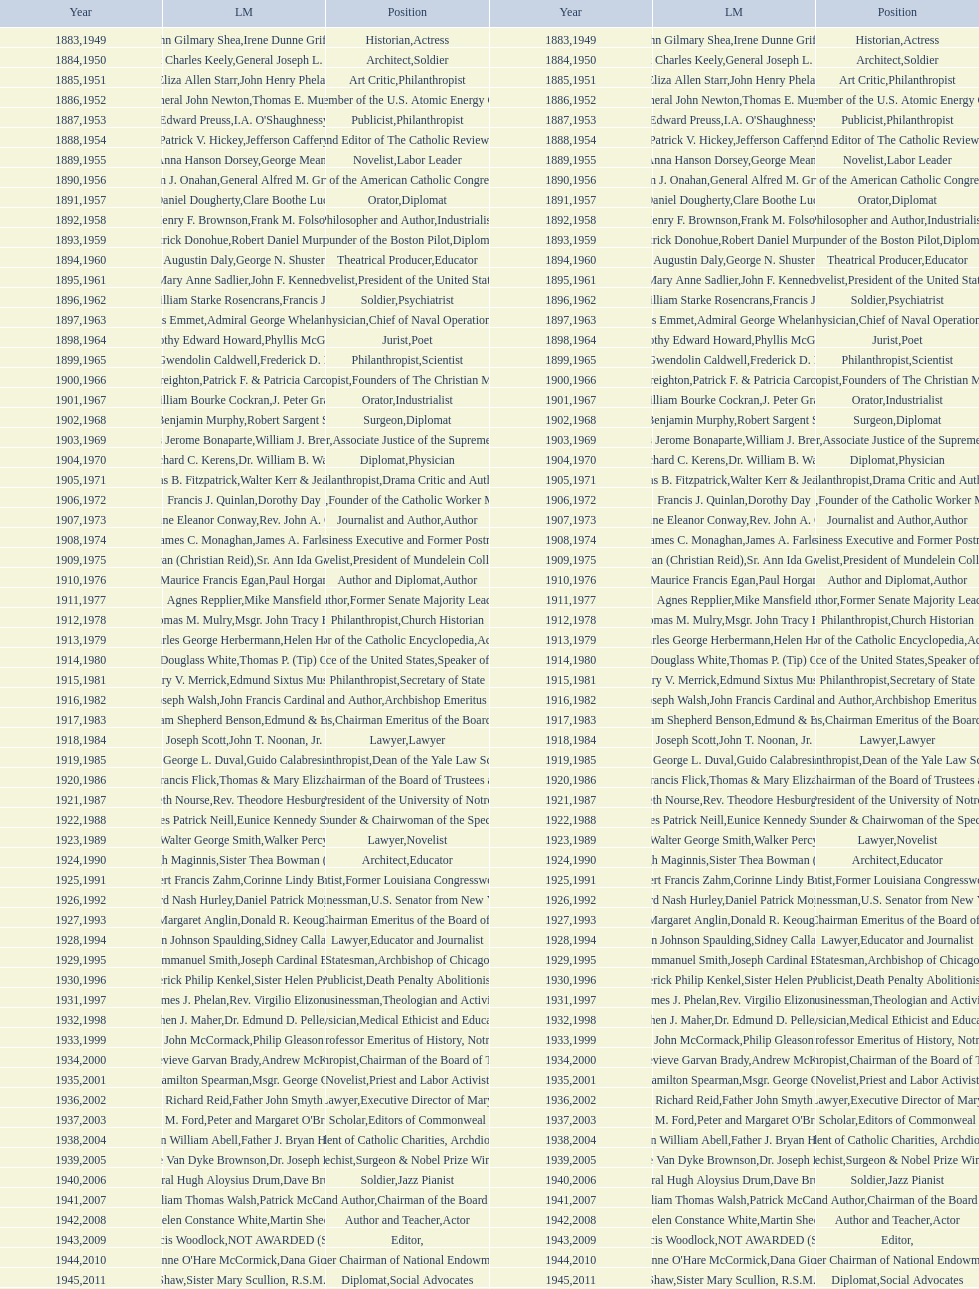Who was the recipient of the medal after thomas e. murray in 1952? I.A. O'Shaughnessy. 